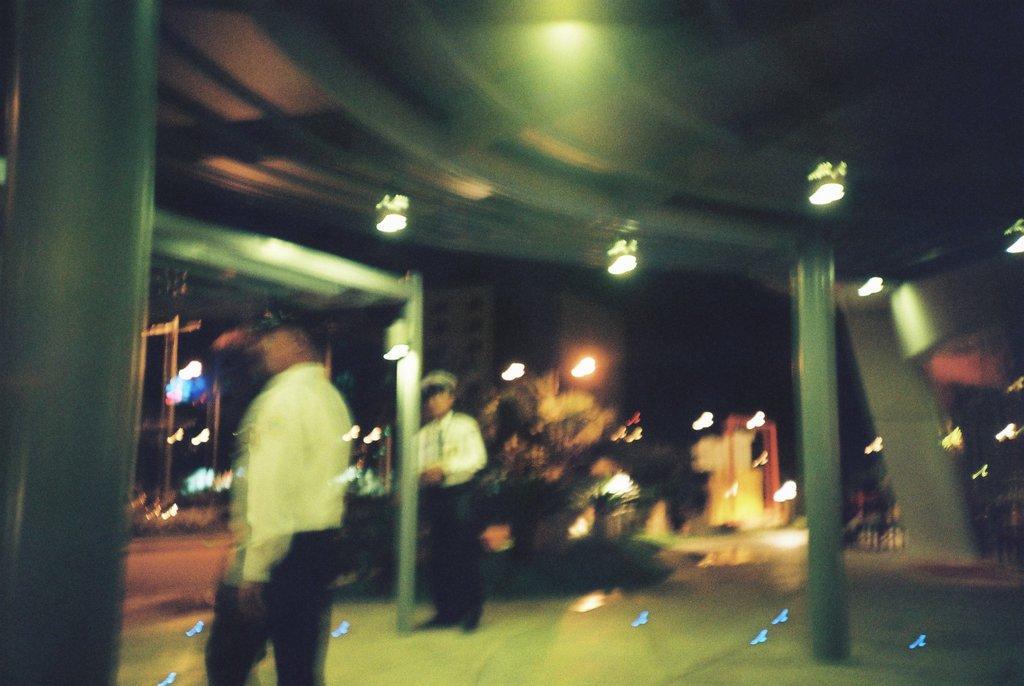In one or two sentences, can you explain what this image depicts? In this image there are two persons standing, there are lights, buildings, road and there are trees. 